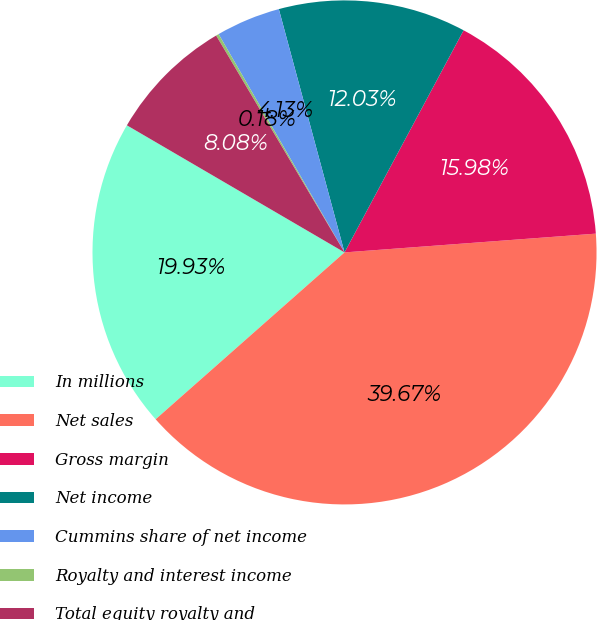Convert chart to OTSL. <chart><loc_0><loc_0><loc_500><loc_500><pie_chart><fcel>In millions<fcel>Net sales<fcel>Gross margin<fcel>Net income<fcel>Cummins share of net income<fcel>Royalty and interest income<fcel>Total equity royalty and<nl><fcel>19.93%<fcel>39.67%<fcel>15.98%<fcel>12.03%<fcel>4.13%<fcel>0.18%<fcel>8.08%<nl></chart> 